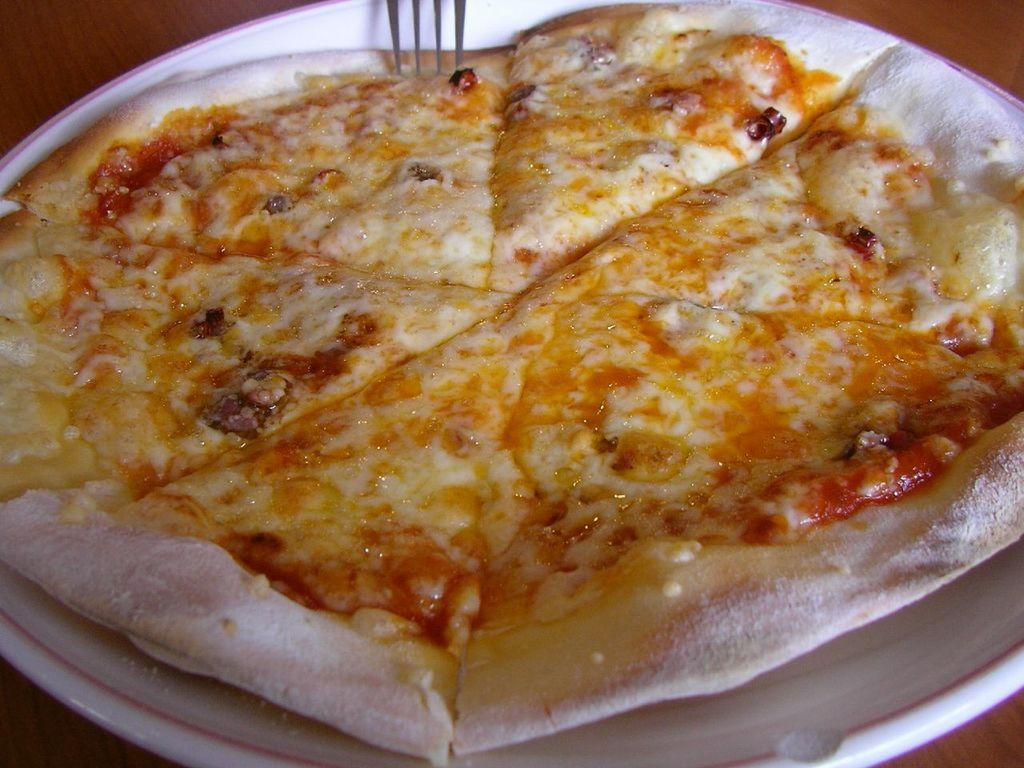What is on the plate in the image? There is food on a plate in the image. What utensil is visible in the image? There is a fork visible in the image. What type of trousers are being worn by the food in the image? There are no people or clothing items present in the image, as it only features food on a plate and a fork. 